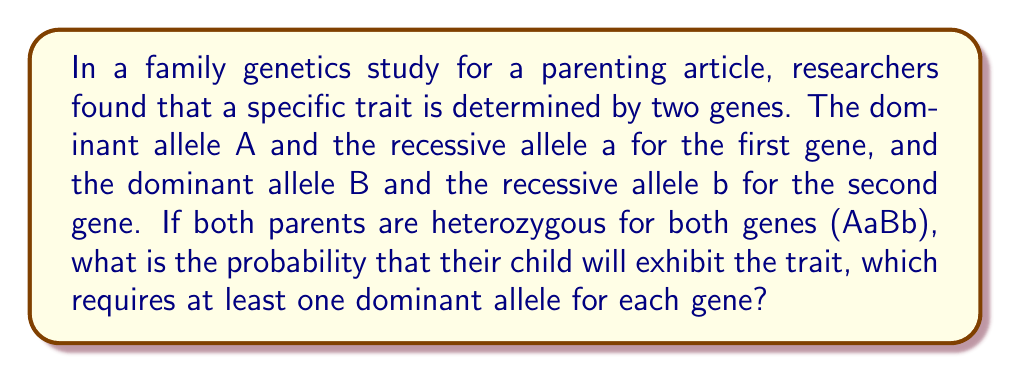Can you solve this math problem? Let's approach this step-by-step:

1) For a child to exhibit the trait, they need at least one A allele AND at least one B allele.

2) The probability of NOT having the trait is the probability of being homozygous recessive for either gene (aa or bb or both).

3) For each parent (AaBb), the possible gametes are:
   AB, Ab, aB, ab (each with 1/4 probability)

4) The probability of the child being aa:
   $P(aa) = \frac{1}{2} \times \frac{1}{2} = \frac{1}{4}$

5) The probability of the child being bb:
   $P(bb) = \frac{1}{2} \times \frac{1}{2} = \frac{1}{4}$

6) The probability of the child being aa OR bb:
   $P(aa \text{ or } bb) = P(aa) + P(bb) - P(aa \text{ and } bb)$
   $= \frac{1}{4} + \frac{1}{4} - (\frac{1}{4} \times \frac{1}{4}) = \frac{1}{2} - \frac{1}{16} = \frac{7}{16}$

7) Therefore, the probability of the child exhibiting the trait is:
   $P(\text{trait}) = 1 - P(aa \text{ or } bb) = 1 - \frac{7}{16} = \frac{9}{16}$
Answer: $\frac{9}{16}$ 